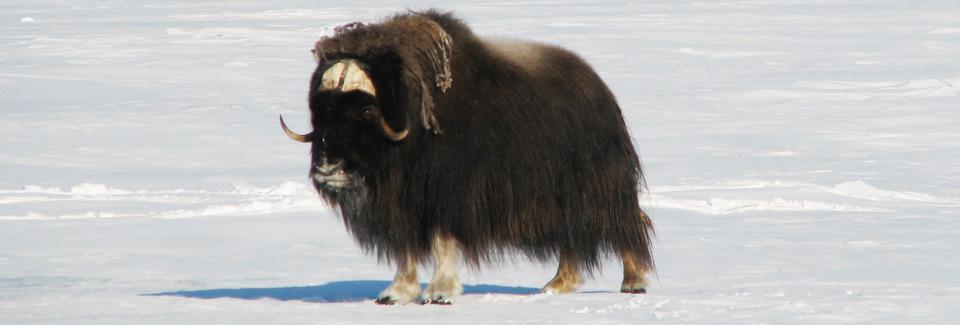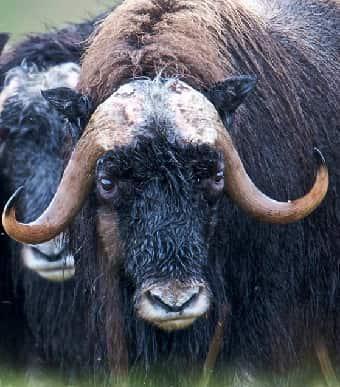The first image is the image on the left, the second image is the image on the right. For the images displayed, is the sentence "There are 8 or more buffalo present in the snow." factually correct? Answer yes or no. No. The first image is the image on the left, the second image is the image on the right. Examine the images to the left and right. Is the description "In the left photo, there is only one buffalo." accurate? Answer yes or no. Yes. 